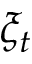Convert formula to latex. <formula><loc_0><loc_0><loc_500><loc_500>\xi _ { t }</formula> 